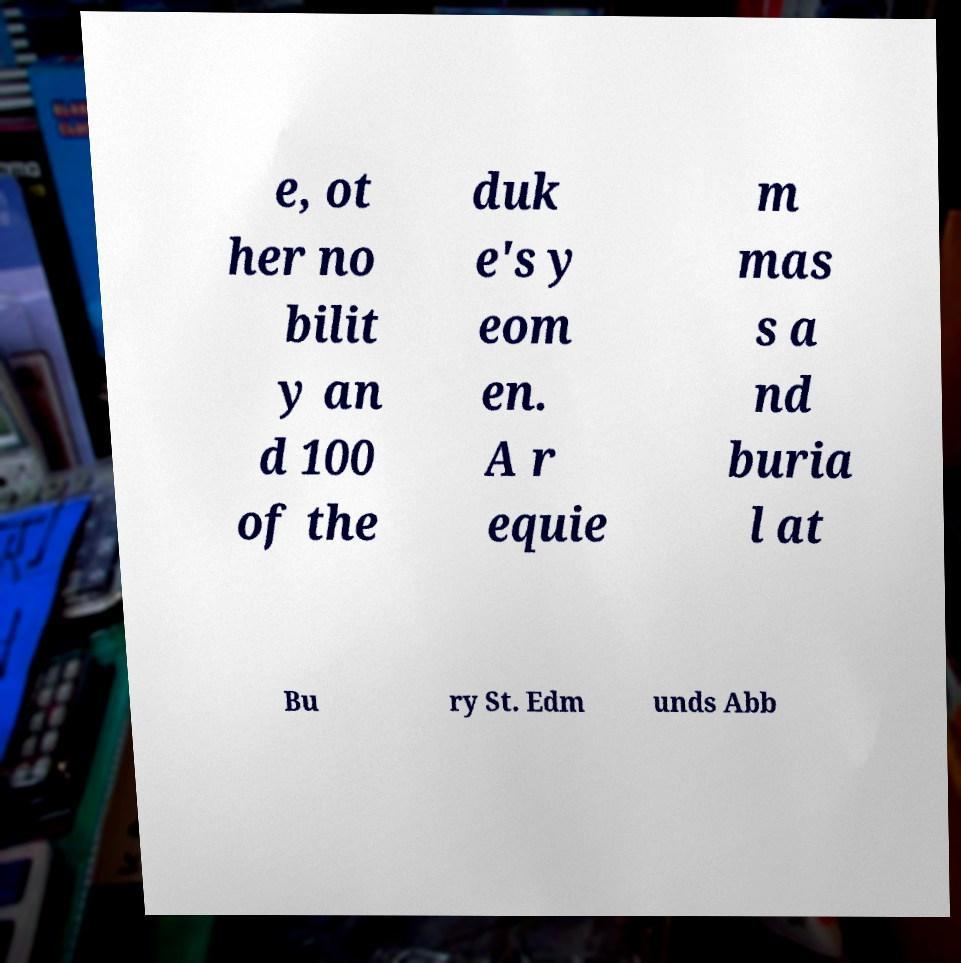What messages or text are displayed in this image? I need them in a readable, typed format. e, ot her no bilit y an d 100 of the duk e's y eom en. A r equie m mas s a nd buria l at Bu ry St. Edm unds Abb 